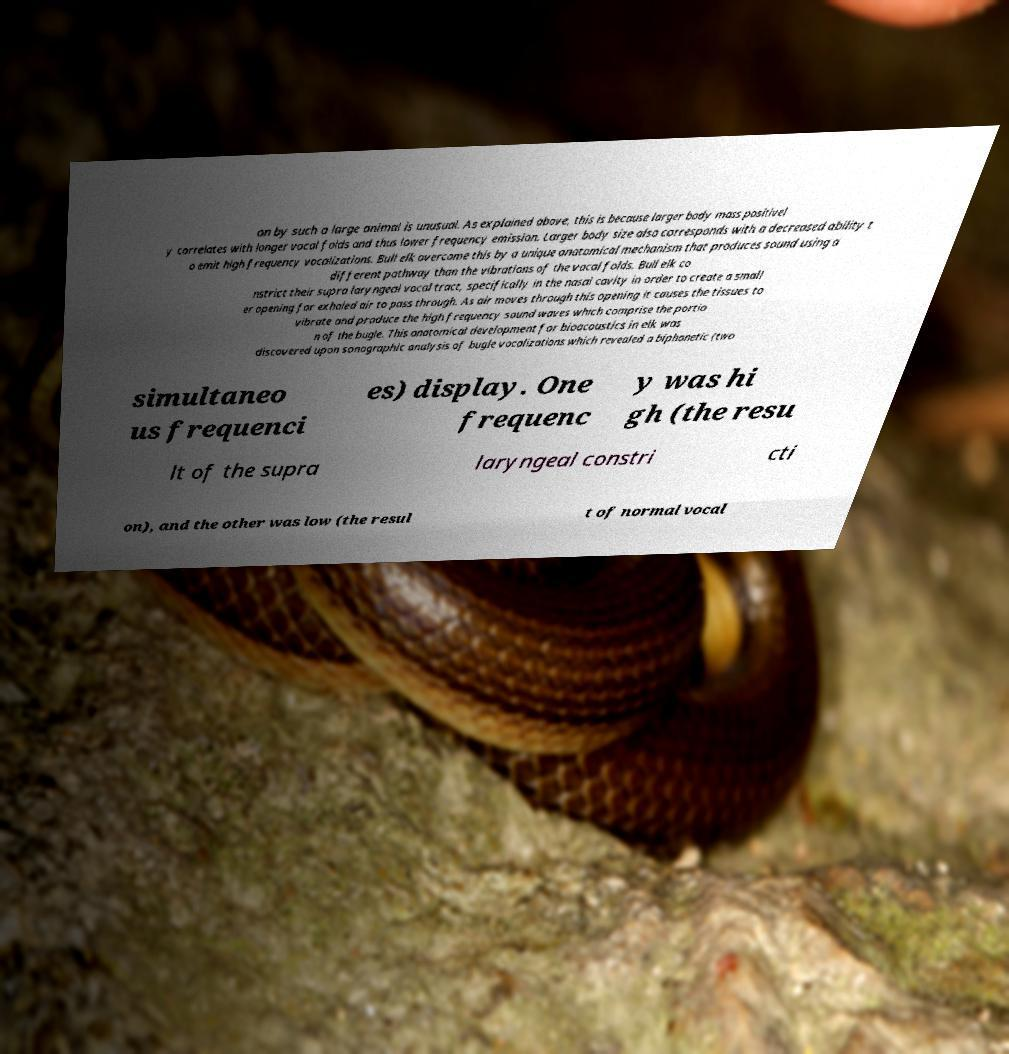Can you read and provide the text displayed in the image?This photo seems to have some interesting text. Can you extract and type it out for me? on by such a large animal is unusual. As explained above, this is because larger body mass positivel y correlates with longer vocal folds and thus lower frequency emission. Larger body size also corresponds with a decreased ability t o emit high frequency vocalizations. Bull elk overcome this by a unique anatomical mechanism that produces sound using a different pathway than the vibrations of the vocal folds. Bull elk co nstrict their supra laryngeal vocal tract, specifically in the nasal cavity in order to create a small er opening for exhaled air to pass through. As air moves through this opening it causes the tissues to vibrate and produce the high frequency sound waves which comprise the portio n of the bugle. This anatomical development for bioacoustics in elk was discovered upon sonographic analysis of bugle vocalizations which revealed a biphonetic (two simultaneo us frequenci es) display. One frequenc y was hi gh (the resu lt of the supra laryngeal constri cti on), and the other was low (the resul t of normal vocal 